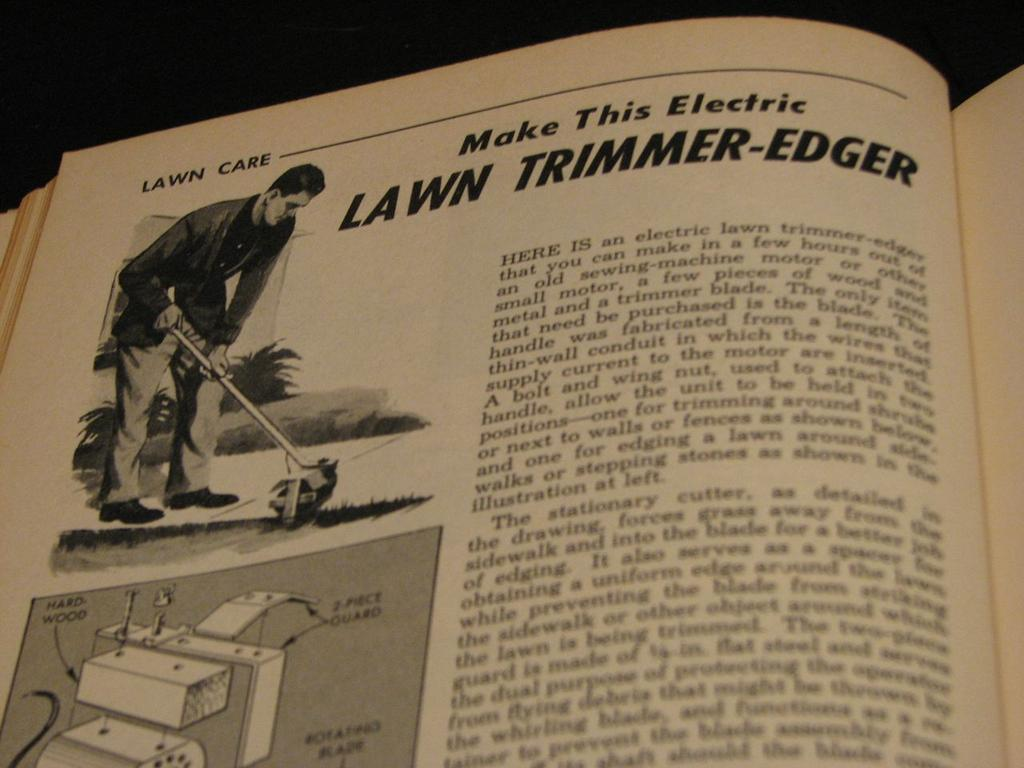<image>
Relay a brief, clear account of the picture shown. An instructional article about how to make a lawn trimmer and edger features a schematic of the product. 